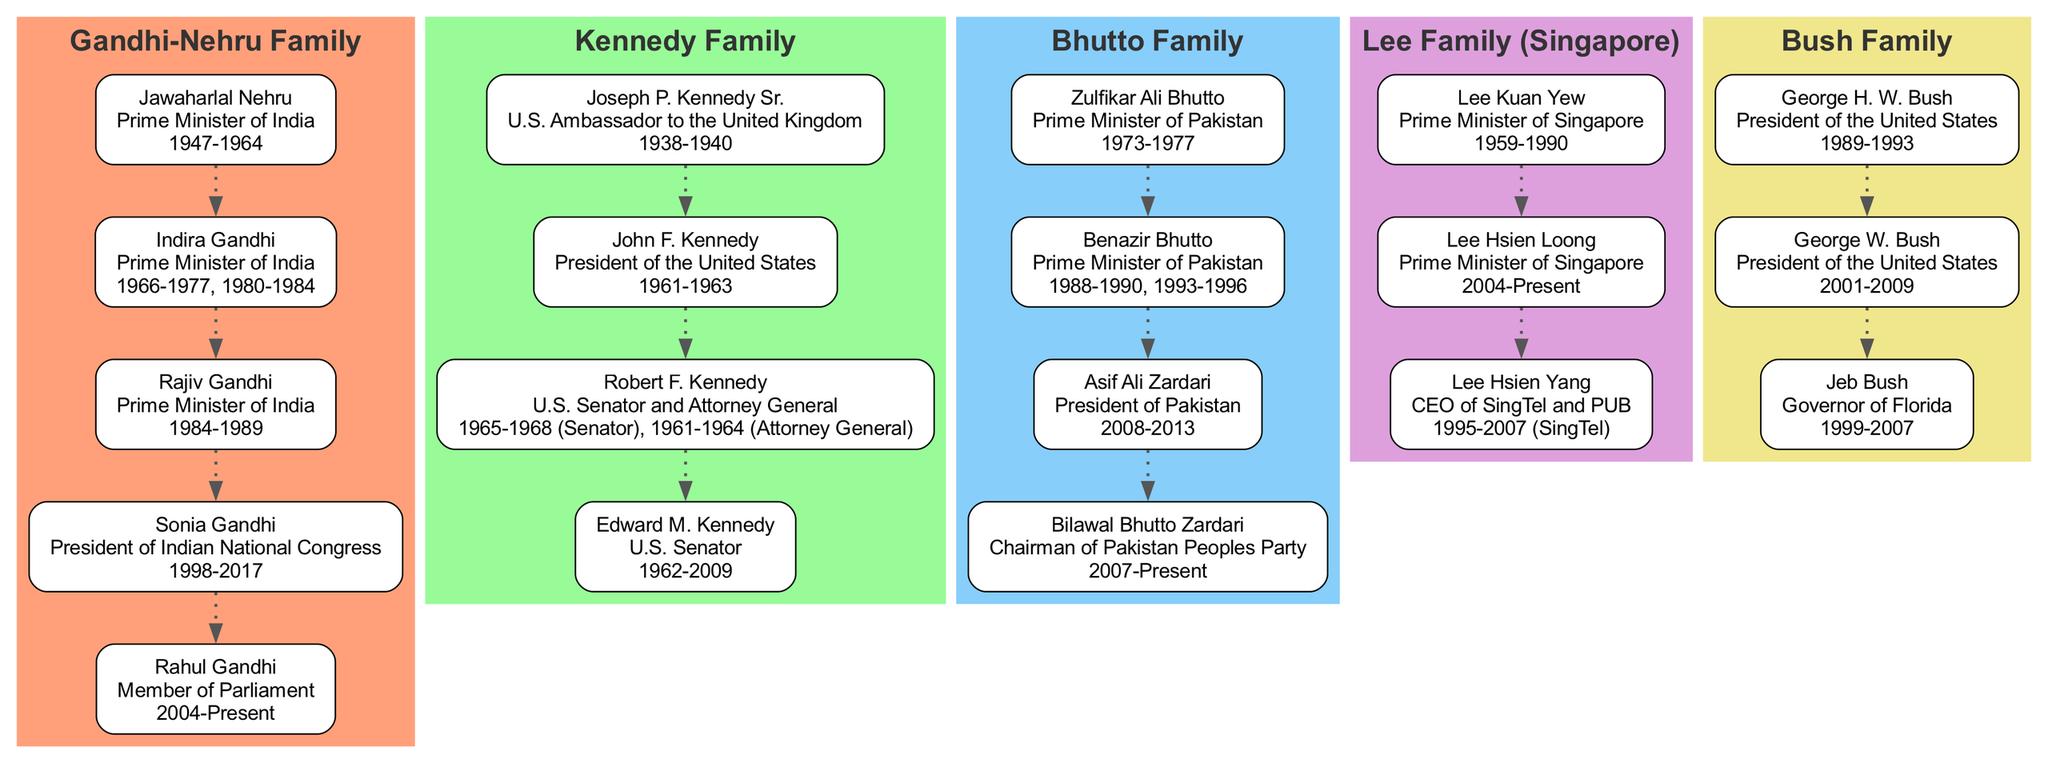What is the role of Jawaharlal Nehru? According to the diagram, Jawaharlal Nehru is listed with the role "Prime Minister of India." This can be found by locating his node within the Gandhi-Nehru family section of the diagram.
Answer: Prime Minister of India Who served as President of the United States after John F. Kennedy? The diagram shows that after John F. Kennedy, Lyndon B. Johnson served as President. Although he is not displayed in the Kennedy family section, a comparison can be made with U.S. presidential history.
Answer: Lyndon B. Johnson How many members are in the Bhutto Family? By counting the nodes in the Bhutto Family section of the diagram, there are four members: Zulfikar Ali Bhutto, Benazir Bhutto, Asif Ali Zardari, and Bilawal Bhutto Zardari.
Answer: 4 Which family has the member currently serving as Prime Minister? Looking at the diagram, the Lee family has Lee Hsien Loong, who is designated as the "Prime Minister of Singapore" and is highlighted as currently serving.
Answer: Lee Family What years did Indira Gandhi serve as Prime Minister of India? The diagram specifies that Indira Gandhi served as Prime Minister in two distinct periods: from 1966 to 1977 and then again from 1980 to 1984. This information can be found in her node in the Gandhi-Nehru Family section.
Answer: 1966-1977, 1980-1984 Which family is associated with the role of Chairman of Pakistan Peoples Party? The node for Bilawal Bhutto Zardari in the Bhutto Family section indicates he is the "Chairman of Pakistan Peoples Party," directly connecting him to that political role.
Answer: Bhutto Family Which two members of the Bush Family served as President? By reviewing both George H. W. Bush and George W. Bush's nodes, it is clear that both held the title of President of the United States, listed consecutively in the diagram.
Answer: George H. W. Bush and George W. Bush What is the highest political office held by a member of the Kennedy Family? The highest political office held by a Kennedy family member, as per the diagram, is that of "President of the United States," which is shown under the John F. Kennedy node.
Answer: President of the United States In which family is a member serving as President of Pakistan? Checking the Bhutto family section leads to Asif Ali Zardari, who is noted as serving as "President of Pakistan," indicating the family's direct involvement in national leadership.
Answer: Bhutto Family 